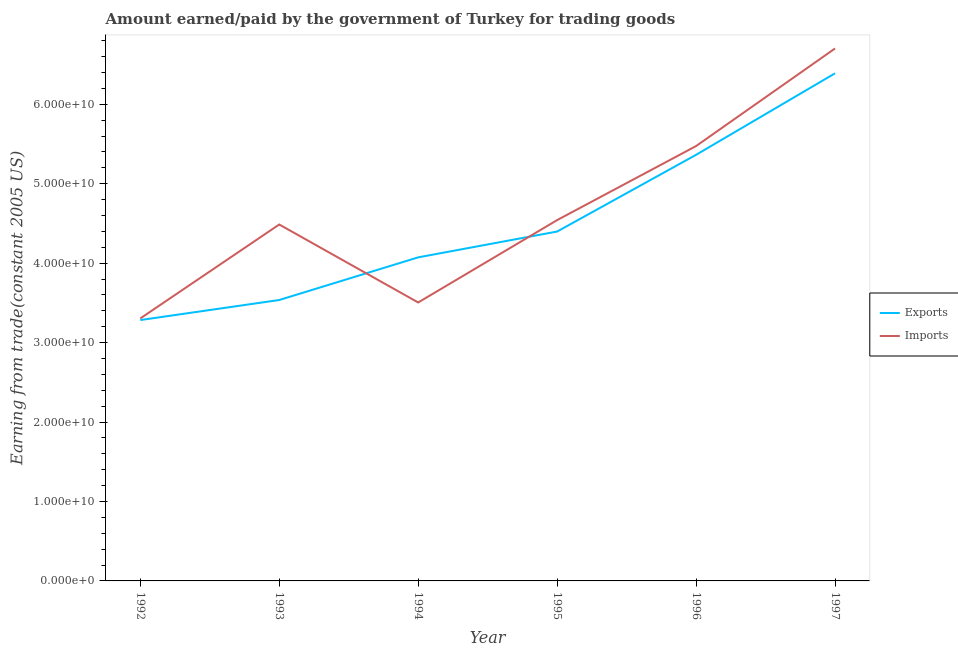Is the number of lines equal to the number of legend labels?
Your answer should be compact. Yes. What is the amount paid for imports in 1994?
Offer a very short reply. 3.51e+1. Across all years, what is the maximum amount paid for imports?
Provide a succinct answer. 6.70e+1. Across all years, what is the minimum amount paid for imports?
Make the answer very short. 3.30e+1. In which year was the amount paid for imports minimum?
Your answer should be compact. 1992. What is the total amount paid for imports in the graph?
Give a very brief answer. 2.80e+11. What is the difference between the amount paid for imports in 1995 and that in 1997?
Your response must be concise. -2.16e+1. What is the difference between the amount earned from exports in 1993 and the amount paid for imports in 1994?
Your response must be concise. 3.10e+08. What is the average amount earned from exports per year?
Ensure brevity in your answer.  4.51e+1. In the year 1992, what is the difference between the amount earned from exports and amount paid for imports?
Provide a succinct answer. -2.04e+08. What is the ratio of the amount earned from exports in 1992 to that in 1994?
Keep it short and to the point. 0.81. Is the amount earned from exports in 1993 less than that in 1996?
Keep it short and to the point. Yes. Is the difference between the amount paid for imports in 1993 and 1997 greater than the difference between the amount earned from exports in 1993 and 1997?
Provide a succinct answer. Yes. What is the difference between the highest and the second highest amount earned from exports?
Keep it short and to the point. 1.03e+1. What is the difference between the highest and the lowest amount earned from exports?
Your answer should be compact. 3.11e+1. How many lines are there?
Your answer should be very brief. 2. Does the graph contain any zero values?
Offer a very short reply. No. What is the title of the graph?
Offer a very short reply. Amount earned/paid by the government of Turkey for trading goods. Does "Diarrhea" appear as one of the legend labels in the graph?
Offer a very short reply. No. What is the label or title of the Y-axis?
Ensure brevity in your answer.  Earning from trade(constant 2005 US). What is the Earning from trade(constant 2005 US) in Exports in 1992?
Give a very brief answer. 3.28e+1. What is the Earning from trade(constant 2005 US) of Imports in 1992?
Keep it short and to the point. 3.30e+1. What is the Earning from trade(constant 2005 US) in Exports in 1993?
Offer a very short reply. 3.54e+1. What is the Earning from trade(constant 2005 US) in Imports in 1993?
Your answer should be compact. 4.49e+1. What is the Earning from trade(constant 2005 US) in Exports in 1994?
Keep it short and to the point. 4.07e+1. What is the Earning from trade(constant 2005 US) in Imports in 1994?
Make the answer very short. 3.51e+1. What is the Earning from trade(constant 2005 US) of Exports in 1995?
Offer a terse response. 4.40e+1. What is the Earning from trade(constant 2005 US) in Imports in 1995?
Your response must be concise. 4.54e+1. What is the Earning from trade(constant 2005 US) in Exports in 1996?
Your answer should be compact. 5.36e+1. What is the Earning from trade(constant 2005 US) in Imports in 1996?
Keep it short and to the point. 5.47e+1. What is the Earning from trade(constant 2005 US) of Exports in 1997?
Your answer should be compact. 6.39e+1. What is the Earning from trade(constant 2005 US) in Imports in 1997?
Keep it short and to the point. 6.70e+1. Across all years, what is the maximum Earning from trade(constant 2005 US) in Exports?
Offer a very short reply. 6.39e+1. Across all years, what is the maximum Earning from trade(constant 2005 US) in Imports?
Offer a terse response. 6.70e+1. Across all years, what is the minimum Earning from trade(constant 2005 US) in Exports?
Make the answer very short. 3.28e+1. Across all years, what is the minimum Earning from trade(constant 2005 US) in Imports?
Offer a very short reply. 3.30e+1. What is the total Earning from trade(constant 2005 US) in Exports in the graph?
Offer a terse response. 2.70e+11. What is the total Earning from trade(constant 2005 US) of Imports in the graph?
Keep it short and to the point. 2.80e+11. What is the difference between the Earning from trade(constant 2005 US) of Exports in 1992 and that in 1993?
Your answer should be very brief. -2.52e+09. What is the difference between the Earning from trade(constant 2005 US) in Imports in 1992 and that in 1993?
Keep it short and to the point. -1.18e+1. What is the difference between the Earning from trade(constant 2005 US) of Exports in 1992 and that in 1994?
Your response must be concise. -7.89e+09. What is the difference between the Earning from trade(constant 2005 US) of Imports in 1992 and that in 1994?
Provide a succinct answer. -2.01e+09. What is the difference between the Earning from trade(constant 2005 US) of Exports in 1992 and that in 1995?
Your answer should be compact. -1.11e+1. What is the difference between the Earning from trade(constant 2005 US) in Imports in 1992 and that in 1995?
Your answer should be very brief. -1.24e+1. What is the difference between the Earning from trade(constant 2005 US) of Exports in 1992 and that in 1996?
Offer a very short reply. -2.08e+1. What is the difference between the Earning from trade(constant 2005 US) of Imports in 1992 and that in 1996?
Keep it short and to the point. -2.17e+1. What is the difference between the Earning from trade(constant 2005 US) in Exports in 1992 and that in 1997?
Offer a very short reply. -3.11e+1. What is the difference between the Earning from trade(constant 2005 US) of Imports in 1992 and that in 1997?
Offer a very short reply. -3.40e+1. What is the difference between the Earning from trade(constant 2005 US) in Exports in 1993 and that in 1994?
Offer a terse response. -5.37e+09. What is the difference between the Earning from trade(constant 2005 US) in Imports in 1993 and that in 1994?
Your answer should be compact. 9.81e+09. What is the difference between the Earning from trade(constant 2005 US) in Exports in 1993 and that in 1995?
Your response must be concise. -8.62e+09. What is the difference between the Earning from trade(constant 2005 US) in Imports in 1993 and that in 1995?
Your answer should be very brief. -5.55e+08. What is the difference between the Earning from trade(constant 2005 US) of Exports in 1993 and that in 1996?
Ensure brevity in your answer.  -1.83e+1. What is the difference between the Earning from trade(constant 2005 US) of Imports in 1993 and that in 1996?
Offer a very short reply. -9.88e+09. What is the difference between the Earning from trade(constant 2005 US) of Exports in 1993 and that in 1997?
Offer a terse response. -2.85e+1. What is the difference between the Earning from trade(constant 2005 US) in Imports in 1993 and that in 1997?
Provide a short and direct response. -2.22e+1. What is the difference between the Earning from trade(constant 2005 US) in Exports in 1994 and that in 1995?
Offer a very short reply. -3.25e+09. What is the difference between the Earning from trade(constant 2005 US) in Imports in 1994 and that in 1995?
Ensure brevity in your answer.  -1.04e+1. What is the difference between the Earning from trade(constant 2005 US) of Exports in 1994 and that in 1996?
Give a very brief answer. -1.29e+1. What is the difference between the Earning from trade(constant 2005 US) of Imports in 1994 and that in 1996?
Provide a succinct answer. -1.97e+1. What is the difference between the Earning from trade(constant 2005 US) in Exports in 1994 and that in 1997?
Make the answer very short. -2.32e+1. What is the difference between the Earning from trade(constant 2005 US) in Imports in 1994 and that in 1997?
Your response must be concise. -3.20e+1. What is the difference between the Earning from trade(constant 2005 US) in Exports in 1995 and that in 1996?
Ensure brevity in your answer.  -9.66e+09. What is the difference between the Earning from trade(constant 2005 US) of Imports in 1995 and that in 1996?
Offer a very short reply. -9.32e+09. What is the difference between the Earning from trade(constant 2005 US) in Exports in 1995 and that in 1997?
Give a very brief answer. -1.99e+1. What is the difference between the Earning from trade(constant 2005 US) in Imports in 1995 and that in 1997?
Your answer should be very brief. -2.16e+1. What is the difference between the Earning from trade(constant 2005 US) of Exports in 1996 and that in 1997?
Give a very brief answer. -1.03e+1. What is the difference between the Earning from trade(constant 2005 US) of Imports in 1996 and that in 1997?
Offer a very short reply. -1.23e+1. What is the difference between the Earning from trade(constant 2005 US) of Exports in 1992 and the Earning from trade(constant 2005 US) of Imports in 1993?
Make the answer very short. -1.20e+1. What is the difference between the Earning from trade(constant 2005 US) in Exports in 1992 and the Earning from trade(constant 2005 US) in Imports in 1994?
Offer a very short reply. -2.21e+09. What is the difference between the Earning from trade(constant 2005 US) in Exports in 1992 and the Earning from trade(constant 2005 US) in Imports in 1995?
Your response must be concise. -1.26e+1. What is the difference between the Earning from trade(constant 2005 US) in Exports in 1992 and the Earning from trade(constant 2005 US) in Imports in 1996?
Your answer should be compact. -2.19e+1. What is the difference between the Earning from trade(constant 2005 US) of Exports in 1992 and the Earning from trade(constant 2005 US) of Imports in 1997?
Your response must be concise. -3.42e+1. What is the difference between the Earning from trade(constant 2005 US) of Exports in 1993 and the Earning from trade(constant 2005 US) of Imports in 1994?
Your answer should be compact. 3.10e+08. What is the difference between the Earning from trade(constant 2005 US) in Exports in 1993 and the Earning from trade(constant 2005 US) in Imports in 1995?
Your response must be concise. -1.01e+1. What is the difference between the Earning from trade(constant 2005 US) of Exports in 1993 and the Earning from trade(constant 2005 US) of Imports in 1996?
Offer a terse response. -1.94e+1. What is the difference between the Earning from trade(constant 2005 US) in Exports in 1993 and the Earning from trade(constant 2005 US) in Imports in 1997?
Make the answer very short. -3.17e+1. What is the difference between the Earning from trade(constant 2005 US) of Exports in 1994 and the Earning from trade(constant 2005 US) of Imports in 1995?
Give a very brief answer. -4.69e+09. What is the difference between the Earning from trade(constant 2005 US) of Exports in 1994 and the Earning from trade(constant 2005 US) of Imports in 1996?
Provide a succinct answer. -1.40e+1. What is the difference between the Earning from trade(constant 2005 US) in Exports in 1994 and the Earning from trade(constant 2005 US) in Imports in 1997?
Your response must be concise. -2.63e+1. What is the difference between the Earning from trade(constant 2005 US) in Exports in 1995 and the Earning from trade(constant 2005 US) in Imports in 1996?
Make the answer very short. -1.08e+1. What is the difference between the Earning from trade(constant 2005 US) of Exports in 1995 and the Earning from trade(constant 2005 US) of Imports in 1997?
Your answer should be compact. -2.30e+1. What is the difference between the Earning from trade(constant 2005 US) of Exports in 1996 and the Earning from trade(constant 2005 US) of Imports in 1997?
Offer a terse response. -1.34e+1. What is the average Earning from trade(constant 2005 US) in Exports per year?
Give a very brief answer. 4.51e+1. What is the average Earning from trade(constant 2005 US) in Imports per year?
Your response must be concise. 4.67e+1. In the year 1992, what is the difference between the Earning from trade(constant 2005 US) in Exports and Earning from trade(constant 2005 US) in Imports?
Provide a succinct answer. -2.04e+08. In the year 1993, what is the difference between the Earning from trade(constant 2005 US) in Exports and Earning from trade(constant 2005 US) in Imports?
Provide a short and direct response. -9.50e+09. In the year 1994, what is the difference between the Earning from trade(constant 2005 US) of Exports and Earning from trade(constant 2005 US) of Imports?
Make the answer very short. 5.68e+09. In the year 1995, what is the difference between the Earning from trade(constant 2005 US) of Exports and Earning from trade(constant 2005 US) of Imports?
Give a very brief answer. -1.44e+09. In the year 1996, what is the difference between the Earning from trade(constant 2005 US) of Exports and Earning from trade(constant 2005 US) of Imports?
Ensure brevity in your answer.  -1.10e+09. In the year 1997, what is the difference between the Earning from trade(constant 2005 US) of Exports and Earning from trade(constant 2005 US) of Imports?
Offer a terse response. -3.13e+09. What is the ratio of the Earning from trade(constant 2005 US) of Exports in 1992 to that in 1993?
Your answer should be compact. 0.93. What is the ratio of the Earning from trade(constant 2005 US) of Imports in 1992 to that in 1993?
Provide a short and direct response. 0.74. What is the ratio of the Earning from trade(constant 2005 US) of Exports in 1992 to that in 1994?
Make the answer very short. 0.81. What is the ratio of the Earning from trade(constant 2005 US) of Imports in 1992 to that in 1994?
Give a very brief answer. 0.94. What is the ratio of the Earning from trade(constant 2005 US) in Exports in 1992 to that in 1995?
Your answer should be compact. 0.75. What is the ratio of the Earning from trade(constant 2005 US) of Imports in 1992 to that in 1995?
Offer a terse response. 0.73. What is the ratio of the Earning from trade(constant 2005 US) in Exports in 1992 to that in 1996?
Offer a terse response. 0.61. What is the ratio of the Earning from trade(constant 2005 US) of Imports in 1992 to that in 1996?
Give a very brief answer. 0.6. What is the ratio of the Earning from trade(constant 2005 US) in Exports in 1992 to that in 1997?
Offer a terse response. 0.51. What is the ratio of the Earning from trade(constant 2005 US) in Imports in 1992 to that in 1997?
Your answer should be compact. 0.49. What is the ratio of the Earning from trade(constant 2005 US) in Exports in 1993 to that in 1994?
Make the answer very short. 0.87. What is the ratio of the Earning from trade(constant 2005 US) in Imports in 1993 to that in 1994?
Ensure brevity in your answer.  1.28. What is the ratio of the Earning from trade(constant 2005 US) in Exports in 1993 to that in 1995?
Provide a short and direct response. 0.8. What is the ratio of the Earning from trade(constant 2005 US) in Exports in 1993 to that in 1996?
Offer a very short reply. 0.66. What is the ratio of the Earning from trade(constant 2005 US) in Imports in 1993 to that in 1996?
Provide a short and direct response. 0.82. What is the ratio of the Earning from trade(constant 2005 US) in Exports in 1993 to that in 1997?
Provide a succinct answer. 0.55. What is the ratio of the Earning from trade(constant 2005 US) in Imports in 1993 to that in 1997?
Your answer should be compact. 0.67. What is the ratio of the Earning from trade(constant 2005 US) of Exports in 1994 to that in 1995?
Provide a short and direct response. 0.93. What is the ratio of the Earning from trade(constant 2005 US) of Imports in 1994 to that in 1995?
Provide a short and direct response. 0.77. What is the ratio of the Earning from trade(constant 2005 US) of Exports in 1994 to that in 1996?
Your answer should be very brief. 0.76. What is the ratio of the Earning from trade(constant 2005 US) of Imports in 1994 to that in 1996?
Give a very brief answer. 0.64. What is the ratio of the Earning from trade(constant 2005 US) of Exports in 1994 to that in 1997?
Your response must be concise. 0.64. What is the ratio of the Earning from trade(constant 2005 US) in Imports in 1994 to that in 1997?
Your answer should be very brief. 0.52. What is the ratio of the Earning from trade(constant 2005 US) in Exports in 1995 to that in 1996?
Your answer should be compact. 0.82. What is the ratio of the Earning from trade(constant 2005 US) of Imports in 1995 to that in 1996?
Your response must be concise. 0.83. What is the ratio of the Earning from trade(constant 2005 US) of Exports in 1995 to that in 1997?
Provide a short and direct response. 0.69. What is the ratio of the Earning from trade(constant 2005 US) of Imports in 1995 to that in 1997?
Ensure brevity in your answer.  0.68. What is the ratio of the Earning from trade(constant 2005 US) in Exports in 1996 to that in 1997?
Ensure brevity in your answer.  0.84. What is the ratio of the Earning from trade(constant 2005 US) in Imports in 1996 to that in 1997?
Provide a succinct answer. 0.82. What is the difference between the highest and the second highest Earning from trade(constant 2005 US) in Exports?
Make the answer very short. 1.03e+1. What is the difference between the highest and the second highest Earning from trade(constant 2005 US) of Imports?
Give a very brief answer. 1.23e+1. What is the difference between the highest and the lowest Earning from trade(constant 2005 US) in Exports?
Provide a short and direct response. 3.11e+1. What is the difference between the highest and the lowest Earning from trade(constant 2005 US) of Imports?
Ensure brevity in your answer.  3.40e+1. 